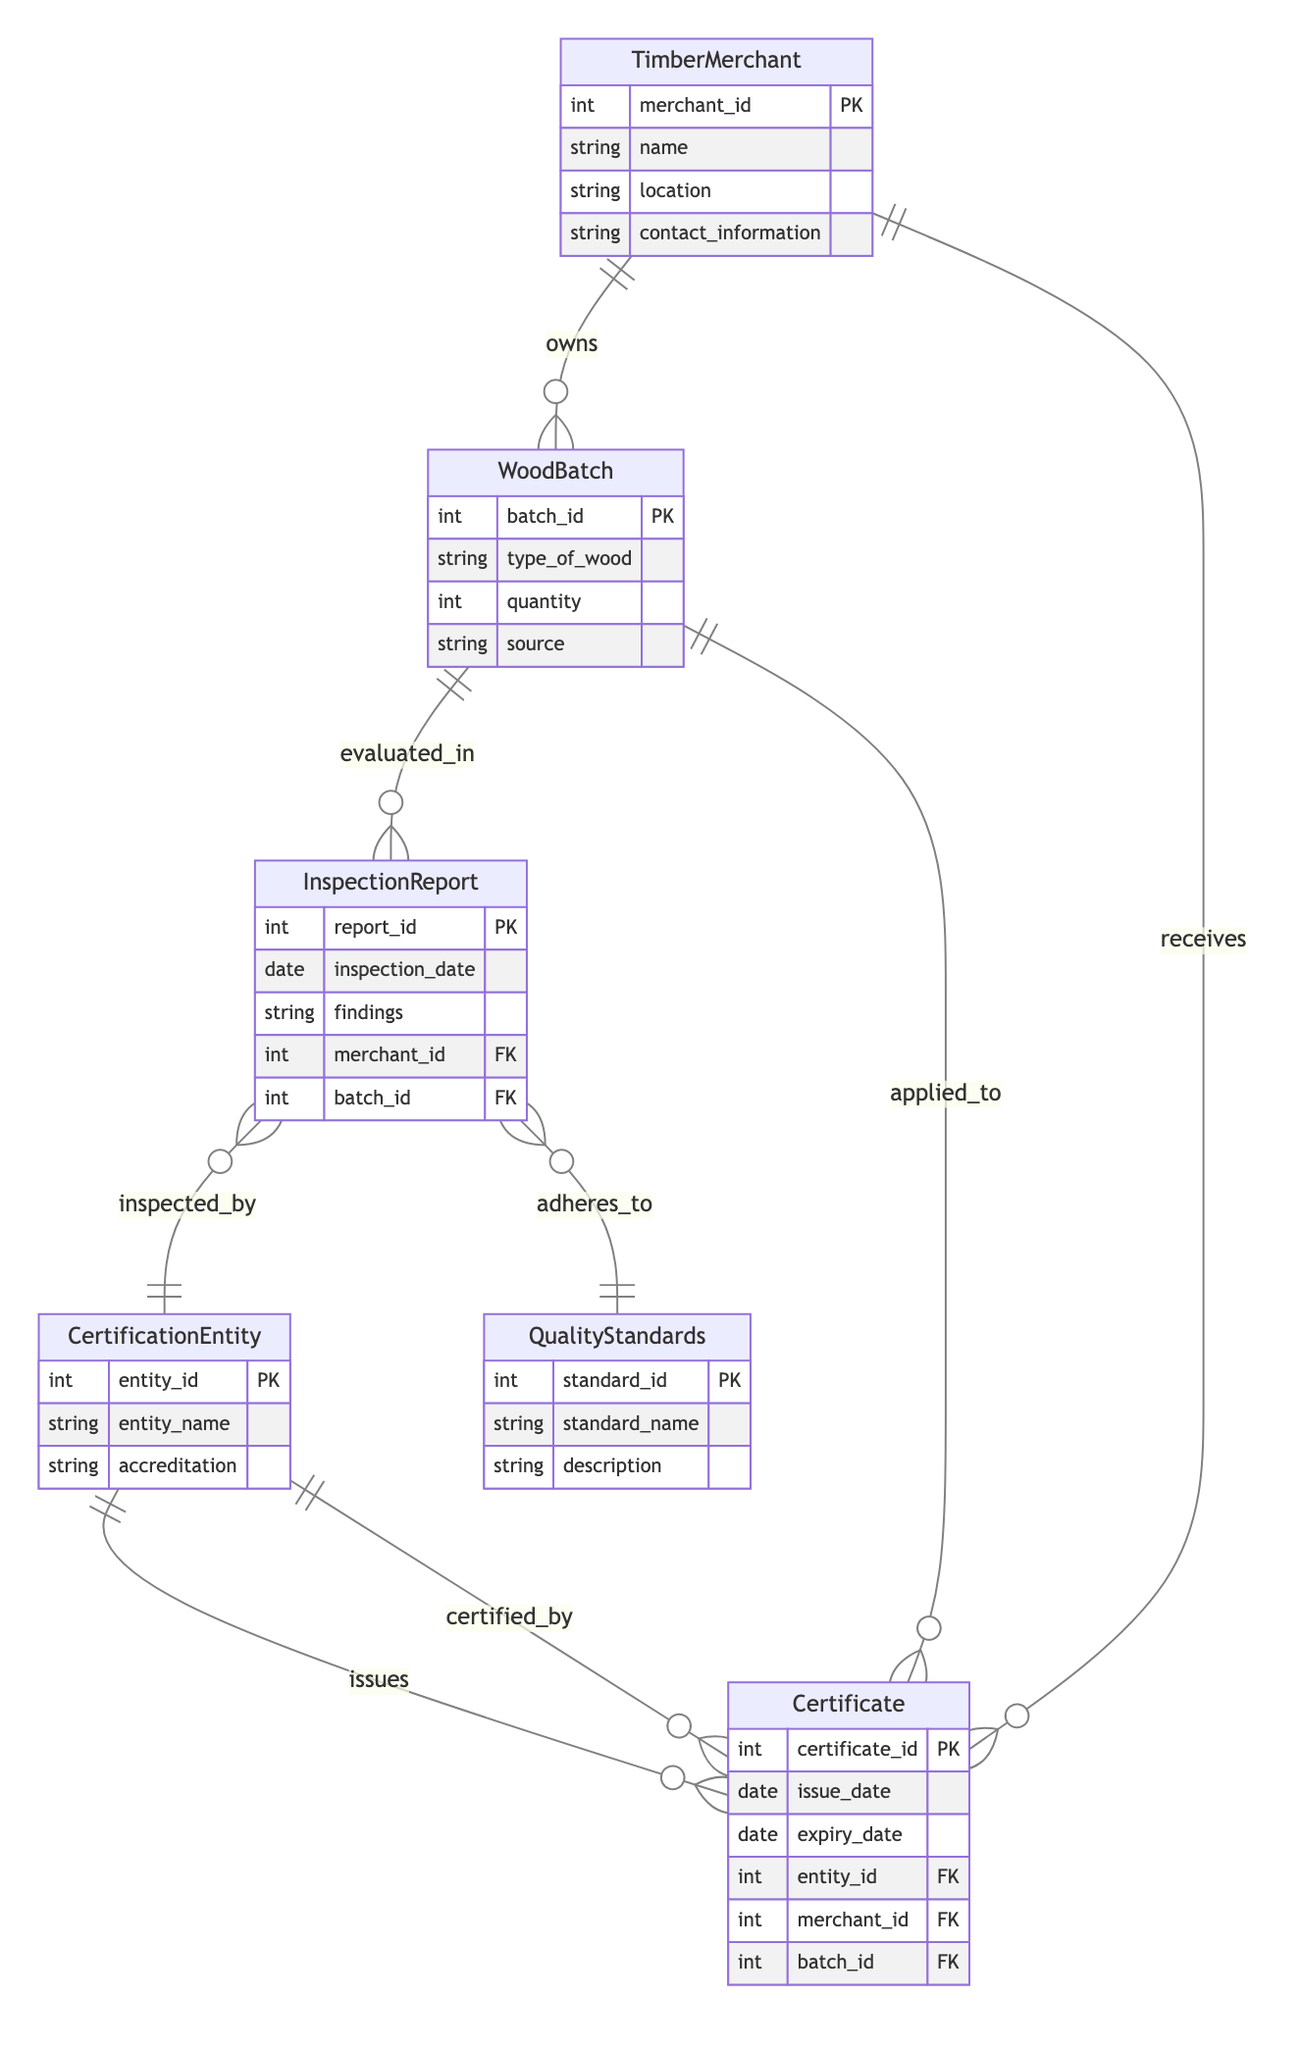What is the primary key of the TimberMerchant entity? The primary key of the TimberMerchant entity is merchant_id, which is a unique identifier for each timber merchant in the system.
Answer: merchant_id How many attributes does the QualityStandards entity have? The QualityStandards entity has three attributes: standard_id, standard_name, and description. Counting these gives a total of three attributes.
Answer: three Which entity is inspected by the InspectionReport? The inspection report is linked to the CertificationEntity through the many-to-one relationship labeled "inspected_by." This indicates that multiple inspection reports can be associated with a single certification entity.
Answer: CertificationEntity What relationship exists between WoodBatch and InspectionReport? The relationship between WoodBatch and InspectionReport is labeled as "evaluated_in," indicating that each wood batch can have multiple inspection reports associated with it.
Answer: evaluated_in Which entity issues the Certificate? The entity that issues the Certificate is the CertificationEntity, as indicated by the "issues" relationship which denotes that one certification entity can issue multiple certificates.
Answer: CertificationEntity How many entities are involved in the certification process depicted in the diagram? There are a total of six entities involved in the certification process: TimberMerchant, WoodBatch, InspectionReport, QualityStandards, CertificationEntity, and Certificate. Therefore, counting these entities gives six.
Answer: six What is the foreign key in the InspectionReport entity? The InspectionReport entity contains two foreign keys: merchant_id and batch_id, which refer to the TimberMerchant and WoodBatch entities respectively. This allows the report to connect back to the specific merchant and wood batch it evaluates.
Answer: merchant_id, batch_id Which entity does the Certificate apply to? The Certificate applies to the WoodBatch entity, as indicated by the many-to-one relationship labeled "applied_to," which signifies that each certificate can be associated with one wood batch.
Answer: WoodBatch What type of relationship exists between Certificate and CertificationEntity? The type of relationship between Certificate and CertificationEntity is many-to-one, identified as "certified_by," meaning each certificate is associated with one certification entity while a single certification entity can certify multiple certificates.
Answer: many-to-one 